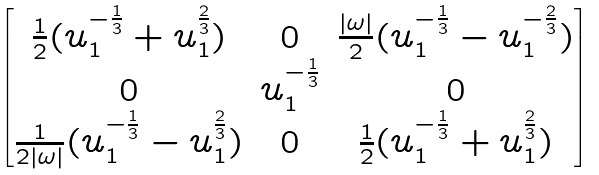Convert formula to latex. <formula><loc_0><loc_0><loc_500><loc_500>\begin{bmatrix} \frac { 1 } { 2 } ( u _ { 1 } ^ { - \frac { 1 } { 3 } } + u _ { 1 } ^ { \frac { 2 } { 3 } } ) & 0 & \frac { | \omega | } { 2 } ( u _ { 1 } ^ { - \frac { 1 } { 3 } } - u _ { 1 } ^ { - \frac { 2 } { 3 } } ) \\ 0 & u _ { 1 } ^ { - \frac { 1 } { 3 } } & 0 \\ \frac { 1 } { 2 | \omega | } ( u _ { 1 } ^ { - \frac { 1 } { 3 } } - u _ { 1 } ^ { \frac { 2 } { 3 } } ) & 0 & \frac { 1 } { 2 } ( u _ { 1 } ^ { - \frac { 1 } { 3 } } + u _ { 1 } ^ { \frac { 2 } { 3 } } ) \end{bmatrix}</formula> 